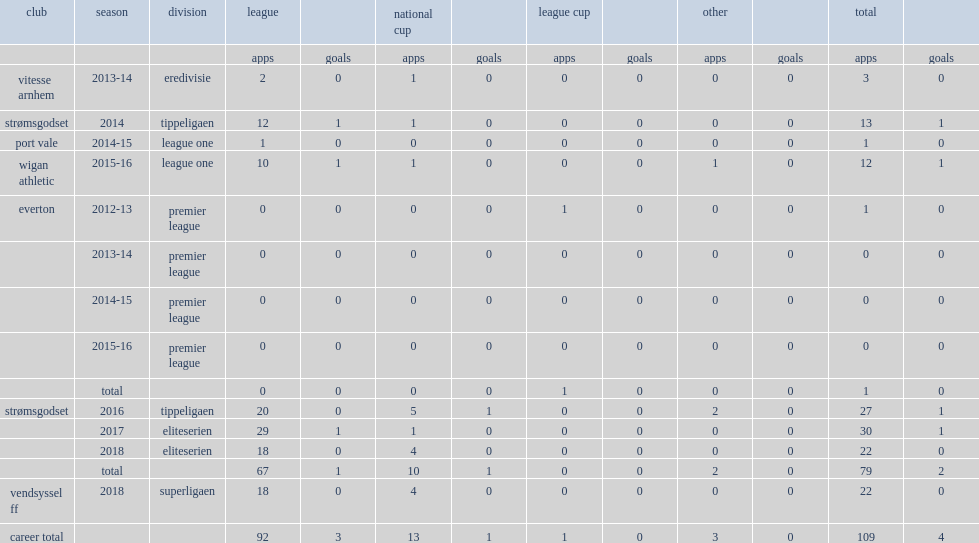Which club did francisco junior play for in 2016? Strømsgodset. 